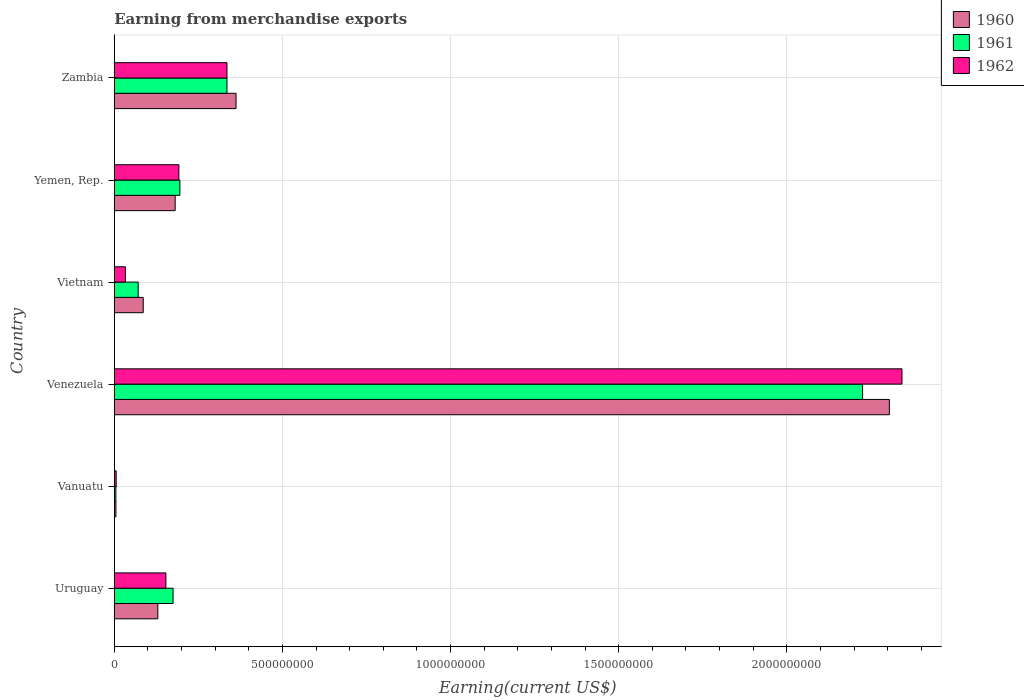How many different coloured bars are there?
Keep it short and to the point. 3. How many groups of bars are there?
Provide a short and direct response. 6. Are the number of bars per tick equal to the number of legend labels?
Keep it short and to the point. Yes. Are the number of bars on each tick of the Y-axis equal?
Give a very brief answer. Yes. What is the label of the 2nd group of bars from the top?
Offer a terse response. Yemen, Rep. What is the amount earned from merchandise exports in 1960 in Uruguay?
Keep it short and to the point. 1.29e+08. Across all countries, what is the maximum amount earned from merchandise exports in 1962?
Ensure brevity in your answer.  2.34e+09. Across all countries, what is the minimum amount earned from merchandise exports in 1960?
Offer a very short reply. 4.78e+06. In which country was the amount earned from merchandise exports in 1960 maximum?
Offer a very short reply. Venezuela. In which country was the amount earned from merchandise exports in 1960 minimum?
Make the answer very short. Vanuatu. What is the total amount earned from merchandise exports in 1962 in the graph?
Keep it short and to the point. 3.06e+09. What is the difference between the amount earned from merchandise exports in 1960 in Uruguay and that in Zambia?
Make the answer very short. -2.33e+08. What is the difference between the amount earned from merchandise exports in 1961 in Vietnam and the amount earned from merchandise exports in 1960 in Uruguay?
Give a very brief answer. -5.84e+07. What is the average amount earned from merchandise exports in 1962 per country?
Your answer should be compact. 5.10e+08. What is the difference between the amount earned from merchandise exports in 1960 and amount earned from merchandise exports in 1961 in Uruguay?
Offer a terse response. -4.53e+07. In how many countries, is the amount earned from merchandise exports in 1961 greater than 1400000000 US$?
Ensure brevity in your answer.  1. What is the ratio of the amount earned from merchandise exports in 1962 in Vanuatu to that in Zambia?
Make the answer very short. 0.02. Is the difference between the amount earned from merchandise exports in 1960 in Vanuatu and Vietnam greater than the difference between the amount earned from merchandise exports in 1961 in Vanuatu and Vietnam?
Give a very brief answer. No. What is the difference between the highest and the second highest amount earned from merchandise exports in 1961?
Ensure brevity in your answer.  1.89e+09. What is the difference between the highest and the lowest amount earned from merchandise exports in 1961?
Your answer should be compact. 2.22e+09. What does the 3rd bar from the bottom in Venezuela represents?
Offer a terse response. 1962. How many bars are there?
Your response must be concise. 18. Are all the bars in the graph horizontal?
Offer a very short reply. Yes. How many countries are there in the graph?
Provide a short and direct response. 6. Does the graph contain any zero values?
Provide a short and direct response. No. How many legend labels are there?
Your answer should be compact. 3. What is the title of the graph?
Ensure brevity in your answer.  Earning from merchandise exports. What is the label or title of the X-axis?
Provide a succinct answer. Earning(current US$). What is the label or title of the Y-axis?
Ensure brevity in your answer.  Country. What is the Earning(current US$) in 1960 in Uruguay?
Your answer should be compact. 1.29e+08. What is the Earning(current US$) of 1961 in Uruguay?
Your answer should be compact. 1.75e+08. What is the Earning(current US$) in 1962 in Uruguay?
Make the answer very short. 1.53e+08. What is the Earning(current US$) of 1960 in Vanuatu?
Offer a very short reply. 4.78e+06. What is the Earning(current US$) of 1961 in Vanuatu?
Offer a very short reply. 4.73e+06. What is the Earning(current US$) of 1962 in Vanuatu?
Offer a terse response. 5.52e+06. What is the Earning(current US$) of 1960 in Venezuela?
Your answer should be very brief. 2.30e+09. What is the Earning(current US$) in 1961 in Venezuela?
Your answer should be very brief. 2.23e+09. What is the Earning(current US$) of 1962 in Venezuela?
Give a very brief answer. 2.34e+09. What is the Earning(current US$) of 1960 in Vietnam?
Your response must be concise. 8.60e+07. What is the Earning(current US$) of 1961 in Vietnam?
Offer a very short reply. 7.10e+07. What is the Earning(current US$) in 1962 in Vietnam?
Ensure brevity in your answer.  3.30e+07. What is the Earning(current US$) in 1960 in Yemen, Rep.?
Make the answer very short. 1.81e+08. What is the Earning(current US$) of 1961 in Yemen, Rep.?
Your answer should be compact. 1.95e+08. What is the Earning(current US$) of 1962 in Yemen, Rep.?
Your answer should be compact. 1.92e+08. What is the Earning(current US$) of 1960 in Zambia?
Your answer should be very brief. 3.62e+08. What is the Earning(current US$) of 1961 in Zambia?
Provide a short and direct response. 3.35e+08. What is the Earning(current US$) in 1962 in Zambia?
Ensure brevity in your answer.  3.35e+08. Across all countries, what is the maximum Earning(current US$) in 1960?
Provide a short and direct response. 2.30e+09. Across all countries, what is the maximum Earning(current US$) in 1961?
Your answer should be very brief. 2.23e+09. Across all countries, what is the maximum Earning(current US$) in 1962?
Your response must be concise. 2.34e+09. Across all countries, what is the minimum Earning(current US$) of 1960?
Give a very brief answer. 4.78e+06. Across all countries, what is the minimum Earning(current US$) of 1961?
Make the answer very short. 4.73e+06. Across all countries, what is the minimum Earning(current US$) of 1962?
Ensure brevity in your answer.  5.52e+06. What is the total Earning(current US$) of 1960 in the graph?
Ensure brevity in your answer.  3.07e+09. What is the total Earning(current US$) in 1961 in the graph?
Give a very brief answer. 3.01e+09. What is the total Earning(current US$) of 1962 in the graph?
Your answer should be very brief. 3.06e+09. What is the difference between the Earning(current US$) in 1960 in Uruguay and that in Vanuatu?
Give a very brief answer. 1.25e+08. What is the difference between the Earning(current US$) of 1961 in Uruguay and that in Vanuatu?
Your response must be concise. 1.70e+08. What is the difference between the Earning(current US$) in 1962 in Uruguay and that in Vanuatu?
Give a very brief answer. 1.48e+08. What is the difference between the Earning(current US$) in 1960 in Uruguay and that in Venezuela?
Keep it short and to the point. -2.18e+09. What is the difference between the Earning(current US$) in 1961 in Uruguay and that in Venezuela?
Your answer should be very brief. -2.05e+09. What is the difference between the Earning(current US$) in 1962 in Uruguay and that in Venezuela?
Ensure brevity in your answer.  -2.19e+09. What is the difference between the Earning(current US$) of 1960 in Uruguay and that in Vietnam?
Give a very brief answer. 4.34e+07. What is the difference between the Earning(current US$) in 1961 in Uruguay and that in Vietnam?
Make the answer very short. 1.04e+08. What is the difference between the Earning(current US$) of 1962 in Uruguay and that in Vietnam?
Make the answer very short. 1.20e+08. What is the difference between the Earning(current US$) of 1960 in Uruguay and that in Yemen, Rep.?
Give a very brief answer. -5.16e+07. What is the difference between the Earning(current US$) in 1961 in Uruguay and that in Yemen, Rep.?
Provide a short and direct response. -2.03e+07. What is the difference between the Earning(current US$) of 1962 in Uruguay and that in Yemen, Rep.?
Offer a terse response. -3.86e+07. What is the difference between the Earning(current US$) of 1960 in Uruguay and that in Zambia?
Ensure brevity in your answer.  -2.33e+08. What is the difference between the Earning(current US$) in 1961 in Uruguay and that in Zambia?
Your answer should be very brief. -1.60e+08. What is the difference between the Earning(current US$) of 1962 in Uruguay and that in Zambia?
Ensure brevity in your answer.  -1.82e+08. What is the difference between the Earning(current US$) of 1960 in Vanuatu and that in Venezuela?
Ensure brevity in your answer.  -2.30e+09. What is the difference between the Earning(current US$) of 1961 in Vanuatu and that in Venezuela?
Provide a short and direct response. -2.22e+09. What is the difference between the Earning(current US$) in 1962 in Vanuatu and that in Venezuela?
Make the answer very short. -2.34e+09. What is the difference between the Earning(current US$) in 1960 in Vanuatu and that in Vietnam?
Offer a very short reply. -8.12e+07. What is the difference between the Earning(current US$) of 1961 in Vanuatu and that in Vietnam?
Ensure brevity in your answer.  -6.63e+07. What is the difference between the Earning(current US$) of 1962 in Vanuatu and that in Vietnam?
Give a very brief answer. -2.75e+07. What is the difference between the Earning(current US$) in 1960 in Vanuatu and that in Yemen, Rep.?
Give a very brief answer. -1.76e+08. What is the difference between the Earning(current US$) in 1961 in Vanuatu and that in Yemen, Rep.?
Your response must be concise. -1.90e+08. What is the difference between the Earning(current US$) of 1962 in Vanuatu and that in Yemen, Rep.?
Offer a very short reply. -1.86e+08. What is the difference between the Earning(current US$) of 1960 in Vanuatu and that in Zambia?
Your answer should be compact. -3.57e+08. What is the difference between the Earning(current US$) of 1961 in Vanuatu and that in Zambia?
Provide a short and direct response. -3.30e+08. What is the difference between the Earning(current US$) in 1962 in Vanuatu and that in Zambia?
Provide a succinct answer. -3.29e+08. What is the difference between the Earning(current US$) of 1960 in Venezuela and that in Vietnam?
Your answer should be very brief. 2.22e+09. What is the difference between the Earning(current US$) of 1961 in Venezuela and that in Vietnam?
Your response must be concise. 2.15e+09. What is the difference between the Earning(current US$) in 1962 in Venezuela and that in Vietnam?
Your response must be concise. 2.31e+09. What is the difference between the Earning(current US$) in 1960 in Venezuela and that in Yemen, Rep.?
Your response must be concise. 2.12e+09. What is the difference between the Earning(current US$) of 1961 in Venezuela and that in Yemen, Rep.?
Ensure brevity in your answer.  2.03e+09. What is the difference between the Earning(current US$) in 1962 in Venezuela and that in Yemen, Rep.?
Provide a short and direct response. 2.15e+09. What is the difference between the Earning(current US$) of 1960 in Venezuela and that in Zambia?
Give a very brief answer. 1.94e+09. What is the difference between the Earning(current US$) of 1961 in Venezuela and that in Zambia?
Keep it short and to the point. 1.89e+09. What is the difference between the Earning(current US$) of 1962 in Venezuela and that in Zambia?
Offer a very short reply. 2.01e+09. What is the difference between the Earning(current US$) of 1960 in Vietnam and that in Yemen, Rep.?
Your answer should be compact. -9.50e+07. What is the difference between the Earning(current US$) of 1961 in Vietnam and that in Yemen, Rep.?
Your answer should be compact. -1.24e+08. What is the difference between the Earning(current US$) of 1962 in Vietnam and that in Yemen, Rep.?
Your answer should be very brief. -1.59e+08. What is the difference between the Earning(current US$) in 1960 in Vietnam and that in Zambia?
Ensure brevity in your answer.  -2.76e+08. What is the difference between the Earning(current US$) of 1961 in Vietnam and that in Zambia?
Your response must be concise. -2.64e+08. What is the difference between the Earning(current US$) in 1962 in Vietnam and that in Zambia?
Provide a short and direct response. -3.02e+08. What is the difference between the Earning(current US$) in 1960 in Yemen, Rep. and that in Zambia?
Provide a succinct answer. -1.81e+08. What is the difference between the Earning(current US$) in 1961 in Yemen, Rep. and that in Zambia?
Your response must be concise. -1.40e+08. What is the difference between the Earning(current US$) in 1962 in Yemen, Rep. and that in Zambia?
Your answer should be compact. -1.43e+08. What is the difference between the Earning(current US$) of 1960 in Uruguay and the Earning(current US$) of 1961 in Vanuatu?
Ensure brevity in your answer.  1.25e+08. What is the difference between the Earning(current US$) in 1960 in Uruguay and the Earning(current US$) in 1962 in Vanuatu?
Your response must be concise. 1.24e+08. What is the difference between the Earning(current US$) in 1961 in Uruguay and the Earning(current US$) in 1962 in Vanuatu?
Provide a short and direct response. 1.69e+08. What is the difference between the Earning(current US$) in 1960 in Uruguay and the Earning(current US$) in 1961 in Venezuela?
Keep it short and to the point. -2.10e+09. What is the difference between the Earning(current US$) in 1960 in Uruguay and the Earning(current US$) in 1962 in Venezuela?
Ensure brevity in your answer.  -2.21e+09. What is the difference between the Earning(current US$) of 1961 in Uruguay and the Earning(current US$) of 1962 in Venezuela?
Keep it short and to the point. -2.17e+09. What is the difference between the Earning(current US$) of 1960 in Uruguay and the Earning(current US$) of 1961 in Vietnam?
Ensure brevity in your answer.  5.84e+07. What is the difference between the Earning(current US$) of 1960 in Uruguay and the Earning(current US$) of 1962 in Vietnam?
Offer a very short reply. 9.64e+07. What is the difference between the Earning(current US$) in 1961 in Uruguay and the Earning(current US$) in 1962 in Vietnam?
Provide a succinct answer. 1.42e+08. What is the difference between the Earning(current US$) in 1960 in Uruguay and the Earning(current US$) in 1961 in Yemen, Rep.?
Give a very brief answer. -6.56e+07. What is the difference between the Earning(current US$) of 1960 in Uruguay and the Earning(current US$) of 1962 in Yemen, Rep.?
Make the answer very short. -6.26e+07. What is the difference between the Earning(current US$) of 1961 in Uruguay and the Earning(current US$) of 1962 in Yemen, Rep.?
Your response must be concise. -1.73e+07. What is the difference between the Earning(current US$) of 1960 in Uruguay and the Earning(current US$) of 1961 in Zambia?
Your response must be concise. -2.06e+08. What is the difference between the Earning(current US$) of 1960 in Uruguay and the Earning(current US$) of 1962 in Zambia?
Provide a short and direct response. -2.06e+08. What is the difference between the Earning(current US$) in 1961 in Uruguay and the Earning(current US$) in 1962 in Zambia?
Ensure brevity in your answer.  -1.60e+08. What is the difference between the Earning(current US$) in 1960 in Vanuatu and the Earning(current US$) in 1961 in Venezuela?
Provide a short and direct response. -2.22e+09. What is the difference between the Earning(current US$) in 1960 in Vanuatu and the Earning(current US$) in 1962 in Venezuela?
Your response must be concise. -2.34e+09. What is the difference between the Earning(current US$) in 1961 in Vanuatu and the Earning(current US$) in 1962 in Venezuela?
Ensure brevity in your answer.  -2.34e+09. What is the difference between the Earning(current US$) in 1960 in Vanuatu and the Earning(current US$) in 1961 in Vietnam?
Offer a very short reply. -6.62e+07. What is the difference between the Earning(current US$) in 1960 in Vanuatu and the Earning(current US$) in 1962 in Vietnam?
Offer a terse response. -2.82e+07. What is the difference between the Earning(current US$) of 1961 in Vanuatu and the Earning(current US$) of 1962 in Vietnam?
Provide a short and direct response. -2.83e+07. What is the difference between the Earning(current US$) of 1960 in Vanuatu and the Earning(current US$) of 1961 in Yemen, Rep.?
Keep it short and to the point. -1.90e+08. What is the difference between the Earning(current US$) in 1960 in Vanuatu and the Earning(current US$) in 1962 in Yemen, Rep.?
Make the answer very short. -1.87e+08. What is the difference between the Earning(current US$) of 1961 in Vanuatu and the Earning(current US$) of 1962 in Yemen, Rep.?
Provide a short and direct response. -1.87e+08. What is the difference between the Earning(current US$) of 1960 in Vanuatu and the Earning(current US$) of 1961 in Zambia?
Provide a short and direct response. -3.30e+08. What is the difference between the Earning(current US$) of 1960 in Vanuatu and the Earning(current US$) of 1962 in Zambia?
Make the answer very short. -3.30e+08. What is the difference between the Earning(current US$) in 1961 in Vanuatu and the Earning(current US$) in 1962 in Zambia?
Your answer should be compact. -3.30e+08. What is the difference between the Earning(current US$) in 1960 in Venezuela and the Earning(current US$) in 1961 in Vietnam?
Your answer should be very brief. 2.23e+09. What is the difference between the Earning(current US$) in 1960 in Venezuela and the Earning(current US$) in 1962 in Vietnam?
Offer a very short reply. 2.27e+09. What is the difference between the Earning(current US$) of 1961 in Venezuela and the Earning(current US$) of 1962 in Vietnam?
Make the answer very short. 2.19e+09. What is the difference between the Earning(current US$) in 1960 in Venezuela and the Earning(current US$) in 1961 in Yemen, Rep.?
Keep it short and to the point. 2.11e+09. What is the difference between the Earning(current US$) in 1960 in Venezuela and the Earning(current US$) in 1962 in Yemen, Rep.?
Keep it short and to the point. 2.11e+09. What is the difference between the Earning(current US$) in 1961 in Venezuela and the Earning(current US$) in 1962 in Yemen, Rep.?
Your answer should be very brief. 2.03e+09. What is the difference between the Earning(current US$) of 1960 in Venezuela and the Earning(current US$) of 1961 in Zambia?
Your answer should be compact. 1.97e+09. What is the difference between the Earning(current US$) in 1960 in Venezuela and the Earning(current US$) in 1962 in Zambia?
Your answer should be compact. 1.97e+09. What is the difference between the Earning(current US$) of 1961 in Venezuela and the Earning(current US$) of 1962 in Zambia?
Provide a succinct answer. 1.89e+09. What is the difference between the Earning(current US$) of 1960 in Vietnam and the Earning(current US$) of 1961 in Yemen, Rep.?
Ensure brevity in your answer.  -1.09e+08. What is the difference between the Earning(current US$) in 1960 in Vietnam and the Earning(current US$) in 1962 in Yemen, Rep.?
Make the answer very short. -1.06e+08. What is the difference between the Earning(current US$) in 1961 in Vietnam and the Earning(current US$) in 1962 in Yemen, Rep.?
Keep it short and to the point. -1.21e+08. What is the difference between the Earning(current US$) of 1960 in Vietnam and the Earning(current US$) of 1961 in Zambia?
Provide a succinct answer. -2.49e+08. What is the difference between the Earning(current US$) of 1960 in Vietnam and the Earning(current US$) of 1962 in Zambia?
Ensure brevity in your answer.  -2.49e+08. What is the difference between the Earning(current US$) in 1961 in Vietnam and the Earning(current US$) in 1962 in Zambia?
Provide a succinct answer. -2.64e+08. What is the difference between the Earning(current US$) in 1960 in Yemen, Rep. and the Earning(current US$) in 1961 in Zambia?
Give a very brief answer. -1.54e+08. What is the difference between the Earning(current US$) in 1960 in Yemen, Rep. and the Earning(current US$) in 1962 in Zambia?
Offer a terse response. -1.54e+08. What is the difference between the Earning(current US$) in 1961 in Yemen, Rep. and the Earning(current US$) in 1962 in Zambia?
Offer a very short reply. -1.40e+08. What is the average Earning(current US$) of 1960 per country?
Your answer should be very brief. 5.11e+08. What is the average Earning(current US$) in 1961 per country?
Offer a very short reply. 5.01e+08. What is the average Earning(current US$) in 1962 per country?
Your answer should be very brief. 5.10e+08. What is the difference between the Earning(current US$) in 1960 and Earning(current US$) in 1961 in Uruguay?
Provide a succinct answer. -4.53e+07. What is the difference between the Earning(current US$) in 1960 and Earning(current US$) in 1962 in Uruguay?
Ensure brevity in your answer.  -2.40e+07. What is the difference between the Earning(current US$) of 1961 and Earning(current US$) of 1962 in Uruguay?
Keep it short and to the point. 2.13e+07. What is the difference between the Earning(current US$) in 1960 and Earning(current US$) in 1961 in Vanuatu?
Your response must be concise. 5.01e+04. What is the difference between the Earning(current US$) in 1960 and Earning(current US$) in 1962 in Vanuatu?
Provide a succinct answer. -7.43e+05. What is the difference between the Earning(current US$) in 1961 and Earning(current US$) in 1962 in Vanuatu?
Provide a short and direct response. -7.93e+05. What is the difference between the Earning(current US$) in 1960 and Earning(current US$) in 1961 in Venezuela?
Ensure brevity in your answer.  7.96e+07. What is the difference between the Earning(current US$) in 1960 and Earning(current US$) in 1962 in Venezuela?
Offer a very short reply. -3.75e+07. What is the difference between the Earning(current US$) in 1961 and Earning(current US$) in 1962 in Venezuela?
Your response must be concise. -1.17e+08. What is the difference between the Earning(current US$) of 1960 and Earning(current US$) of 1961 in Vietnam?
Make the answer very short. 1.50e+07. What is the difference between the Earning(current US$) in 1960 and Earning(current US$) in 1962 in Vietnam?
Make the answer very short. 5.30e+07. What is the difference between the Earning(current US$) in 1961 and Earning(current US$) in 1962 in Vietnam?
Give a very brief answer. 3.80e+07. What is the difference between the Earning(current US$) of 1960 and Earning(current US$) of 1961 in Yemen, Rep.?
Keep it short and to the point. -1.40e+07. What is the difference between the Earning(current US$) of 1960 and Earning(current US$) of 1962 in Yemen, Rep.?
Ensure brevity in your answer.  -1.10e+07. What is the difference between the Earning(current US$) of 1960 and Earning(current US$) of 1961 in Zambia?
Keep it short and to the point. 2.70e+07. What is the difference between the Earning(current US$) of 1960 and Earning(current US$) of 1962 in Zambia?
Provide a short and direct response. 2.70e+07. What is the ratio of the Earning(current US$) of 1960 in Uruguay to that in Vanuatu?
Offer a very short reply. 27.08. What is the ratio of the Earning(current US$) in 1961 in Uruguay to that in Vanuatu?
Provide a short and direct response. 36.96. What is the ratio of the Earning(current US$) in 1962 in Uruguay to that in Vanuatu?
Your answer should be compact. 27.79. What is the ratio of the Earning(current US$) in 1960 in Uruguay to that in Venezuela?
Make the answer very short. 0.06. What is the ratio of the Earning(current US$) in 1961 in Uruguay to that in Venezuela?
Keep it short and to the point. 0.08. What is the ratio of the Earning(current US$) of 1962 in Uruguay to that in Venezuela?
Your answer should be very brief. 0.07. What is the ratio of the Earning(current US$) of 1960 in Uruguay to that in Vietnam?
Your response must be concise. 1.5. What is the ratio of the Earning(current US$) in 1961 in Uruguay to that in Vietnam?
Offer a terse response. 2.46. What is the ratio of the Earning(current US$) of 1962 in Uruguay to that in Vietnam?
Provide a succinct answer. 4.65. What is the ratio of the Earning(current US$) in 1960 in Uruguay to that in Yemen, Rep.?
Give a very brief answer. 0.71. What is the ratio of the Earning(current US$) of 1961 in Uruguay to that in Yemen, Rep.?
Keep it short and to the point. 0.9. What is the ratio of the Earning(current US$) of 1962 in Uruguay to that in Yemen, Rep.?
Offer a terse response. 0.8. What is the ratio of the Earning(current US$) in 1960 in Uruguay to that in Zambia?
Provide a short and direct response. 0.36. What is the ratio of the Earning(current US$) in 1961 in Uruguay to that in Zambia?
Ensure brevity in your answer.  0.52. What is the ratio of the Earning(current US$) in 1962 in Uruguay to that in Zambia?
Ensure brevity in your answer.  0.46. What is the ratio of the Earning(current US$) in 1960 in Vanuatu to that in Venezuela?
Ensure brevity in your answer.  0. What is the ratio of the Earning(current US$) of 1961 in Vanuatu to that in Venezuela?
Ensure brevity in your answer.  0. What is the ratio of the Earning(current US$) of 1962 in Vanuatu to that in Venezuela?
Your response must be concise. 0. What is the ratio of the Earning(current US$) in 1960 in Vanuatu to that in Vietnam?
Offer a terse response. 0.06. What is the ratio of the Earning(current US$) in 1961 in Vanuatu to that in Vietnam?
Offer a terse response. 0.07. What is the ratio of the Earning(current US$) in 1962 in Vanuatu to that in Vietnam?
Provide a short and direct response. 0.17. What is the ratio of the Earning(current US$) in 1960 in Vanuatu to that in Yemen, Rep.?
Ensure brevity in your answer.  0.03. What is the ratio of the Earning(current US$) of 1961 in Vanuatu to that in Yemen, Rep.?
Keep it short and to the point. 0.02. What is the ratio of the Earning(current US$) of 1962 in Vanuatu to that in Yemen, Rep.?
Give a very brief answer. 0.03. What is the ratio of the Earning(current US$) in 1960 in Vanuatu to that in Zambia?
Your response must be concise. 0.01. What is the ratio of the Earning(current US$) in 1961 in Vanuatu to that in Zambia?
Ensure brevity in your answer.  0.01. What is the ratio of the Earning(current US$) in 1962 in Vanuatu to that in Zambia?
Provide a short and direct response. 0.02. What is the ratio of the Earning(current US$) in 1960 in Venezuela to that in Vietnam?
Offer a terse response. 26.8. What is the ratio of the Earning(current US$) of 1961 in Venezuela to that in Vietnam?
Provide a succinct answer. 31.34. What is the ratio of the Earning(current US$) in 1962 in Venezuela to that in Vietnam?
Offer a very short reply. 70.98. What is the ratio of the Earning(current US$) of 1960 in Venezuela to that in Yemen, Rep.?
Make the answer very short. 12.73. What is the ratio of the Earning(current US$) in 1961 in Venezuela to that in Yemen, Rep.?
Your answer should be very brief. 11.41. What is the ratio of the Earning(current US$) in 1962 in Venezuela to that in Yemen, Rep.?
Make the answer very short. 12.2. What is the ratio of the Earning(current US$) of 1960 in Venezuela to that in Zambia?
Provide a short and direct response. 6.37. What is the ratio of the Earning(current US$) of 1961 in Venezuela to that in Zambia?
Offer a very short reply. 6.64. What is the ratio of the Earning(current US$) of 1962 in Venezuela to that in Zambia?
Your answer should be very brief. 6.99. What is the ratio of the Earning(current US$) in 1960 in Vietnam to that in Yemen, Rep.?
Your response must be concise. 0.48. What is the ratio of the Earning(current US$) in 1961 in Vietnam to that in Yemen, Rep.?
Provide a succinct answer. 0.36. What is the ratio of the Earning(current US$) in 1962 in Vietnam to that in Yemen, Rep.?
Make the answer very short. 0.17. What is the ratio of the Earning(current US$) in 1960 in Vietnam to that in Zambia?
Give a very brief answer. 0.24. What is the ratio of the Earning(current US$) of 1961 in Vietnam to that in Zambia?
Keep it short and to the point. 0.21. What is the ratio of the Earning(current US$) of 1962 in Vietnam to that in Zambia?
Make the answer very short. 0.1. What is the ratio of the Earning(current US$) in 1960 in Yemen, Rep. to that in Zambia?
Ensure brevity in your answer.  0.5. What is the ratio of the Earning(current US$) of 1961 in Yemen, Rep. to that in Zambia?
Keep it short and to the point. 0.58. What is the ratio of the Earning(current US$) in 1962 in Yemen, Rep. to that in Zambia?
Your answer should be compact. 0.57. What is the difference between the highest and the second highest Earning(current US$) in 1960?
Offer a terse response. 1.94e+09. What is the difference between the highest and the second highest Earning(current US$) in 1961?
Give a very brief answer. 1.89e+09. What is the difference between the highest and the second highest Earning(current US$) in 1962?
Provide a succinct answer. 2.01e+09. What is the difference between the highest and the lowest Earning(current US$) of 1960?
Keep it short and to the point. 2.30e+09. What is the difference between the highest and the lowest Earning(current US$) of 1961?
Ensure brevity in your answer.  2.22e+09. What is the difference between the highest and the lowest Earning(current US$) of 1962?
Provide a short and direct response. 2.34e+09. 